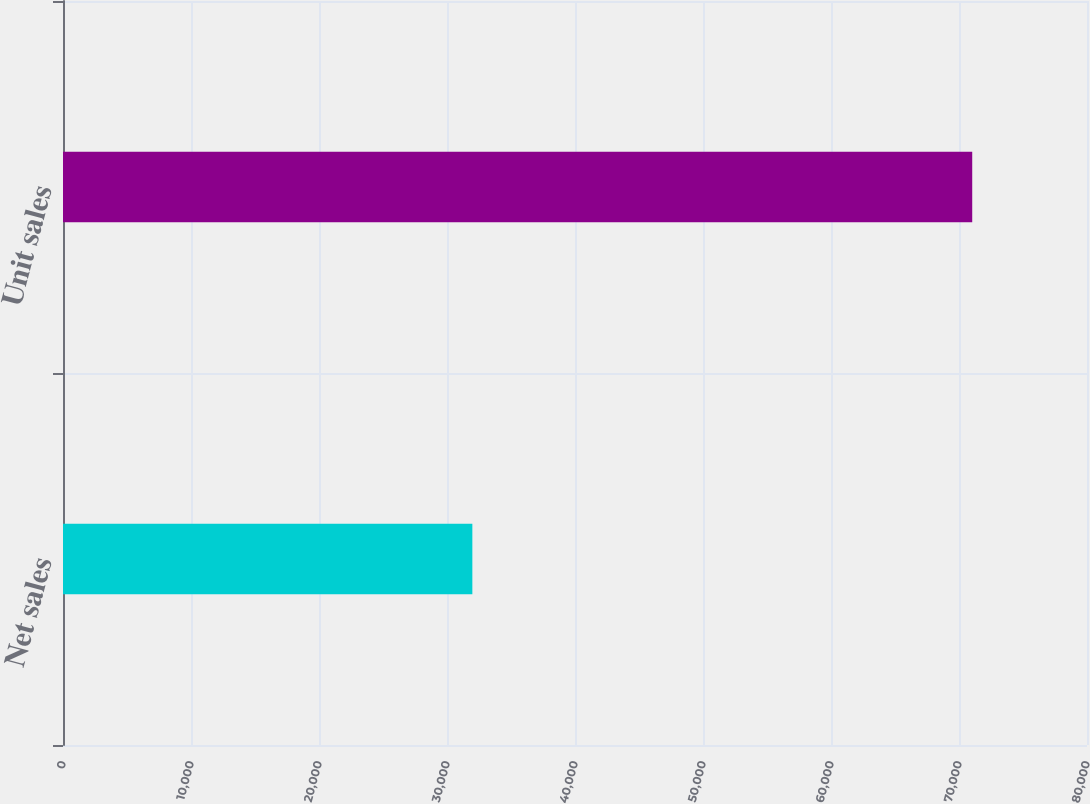<chart> <loc_0><loc_0><loc_500><loc_500><bar_chart><fcel>Net sales<fcel>Unit sales<nl><fcel>31980<fcel>71033<nl></chart> 